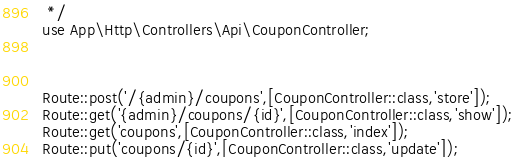Convert code to text. <code><loc_0><loc_0><loc_500><loc_500><_PHP_> */
use App\Http\Controllers\Api\CouponController;



Route::post('/{admin}/coupons',[CouponController::class,'store']);
Route::get('{admin}/coupons/{id}',[CouponController::class,'show']);
Route::get('coupons',[CouponController::class,'index']);
Route::put('coupons/{id}',[CouponController::class,'update']);</code> 